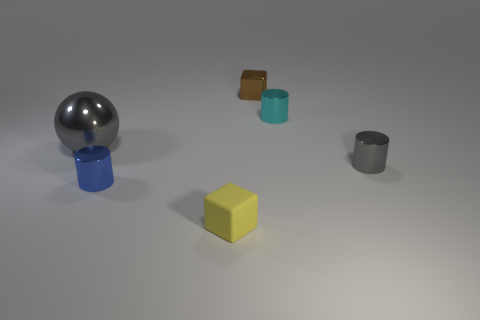What size is the blue thing?
Provide a succinct answer. Small. What is the material of the blue cylinder that is the same size as the cyan cylinder?
Ensure brevity in your answer.  Metal. There is a yellow matte block; what number of small cyan metal cylinders are behind it?
Ensure brevity in your answer.  1. Are the gray thing to the left of the blue cylinder and the tiny cylinder behind the large thing made of the same material?
Your response must be concise. Yes. What is the shape of the gray shiny thing that is right of the small thing that is in front of the small shiny cylinder that is left of the tiny matte thing?
Give a very brief answer. Cylinder. The tiny gray metal thing is what shape?
Give a very brief answer. Cylinder. What is the shape of the blue shiny object that is the same size as the rubber object?
Offer a terse response. Cylinder. How many other things are the same color as the big sphere?
Keep it short and to the point. 1. Is the shape of the gray thing that is in front of the large gray object the same as the shiny thing to the left of the tiny blue cylinder?
Provide a succinct answer. No. What number of objects are either cylinders that are to the left of the tiny gray metallic cylinder or small metal cylinders to the left of the small yellow rubber thing?
Give a very brief answer. 2. 